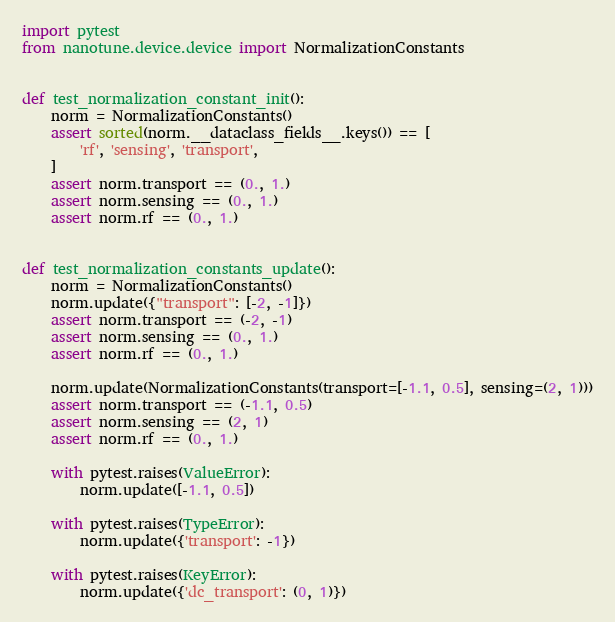<code> <loc_0><loc_0><loc_500><loc_500><_Python_>import pytest
from nanotune.device.device import NormalizationConstants


def test_normalization_constant_init():
    norm = NormalizationConstants()
    assert sorted(norm.__dataclass_fields__.keys()) == [
        'rf', 'sensing', 'transport',
    ]
    assert norm.transport == (0., 1.)
    assert norm.sensing == (0., 1.)
    assert norm.rf == (0., 1.)


def test_normalization_constants_update():
    norm = NormalizationConstants()
    norm.update({"transport": [-2, -1]})
    assert norm.transport == (-2, -1)
    assert norm.sensing == (0., 1.)
    assert norm.rf == (0., 1.)

    norm.update(NormalizationConstants(transport=[-1.1, 0.5], sensing=(2, 1)))
    assert norm.transport == (-1.1, 0.5)
    assert norm.sensing == (2, 1)
    assert norm.rf == (0., 1.)

    with pytest.raises(ValueError):
        norm.update([-1.1, 0.5])

    with pytest.raises(TypeError):
        norm.update({'transport': -1})

    with pytest.raises(KeyError):
        norm.update({'dc_transport': (0, 1)})
</code> 